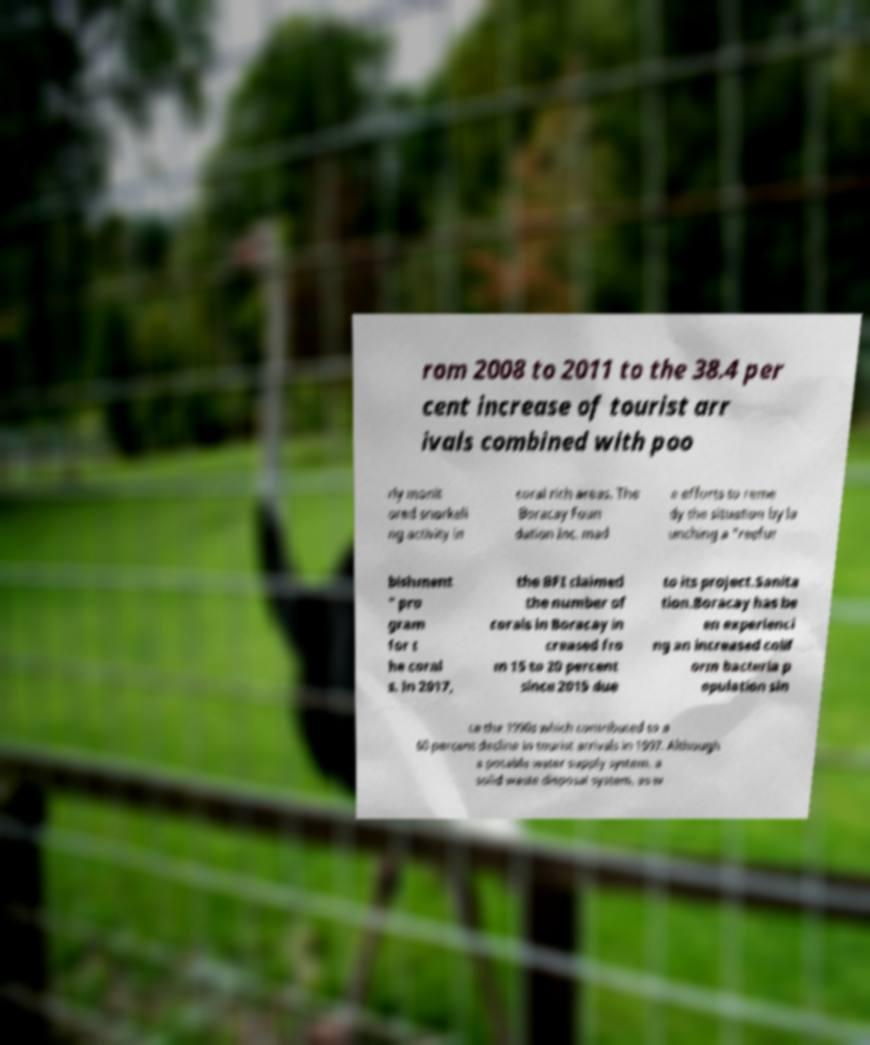Please identify and transcribe the text found in this image. rom 2008 to 2011 to the 38.4 per cent increase of tourist arr ivals combined with poo rly monit ored snorkeli ng activity in coral rich areas. The Boracay Foun dation Inc. mad e efforts to reme dy the situation by la unching a "reefur bishment " pro gram for t he coral s. In 2017, the BFI claimed the number of corals in Boracay in creased fro m 15 to 20 percent since 2015 due to its project.Sanita tion.Boracay has be en experienci ng an increased colif orm bacteria p opulation sin ce the 1990s which contributed to a 60 percent decline in tourist arrivals in 1997. Although a potable water supply system, a solid waste disposal system, as w 